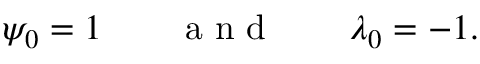<formula> <loc_0><loc_0><loc_500><loc_500>\psi _ { 0 } = 1 \quad a n d \quad \lambda _ { 0 } = - 1 .</formula> 